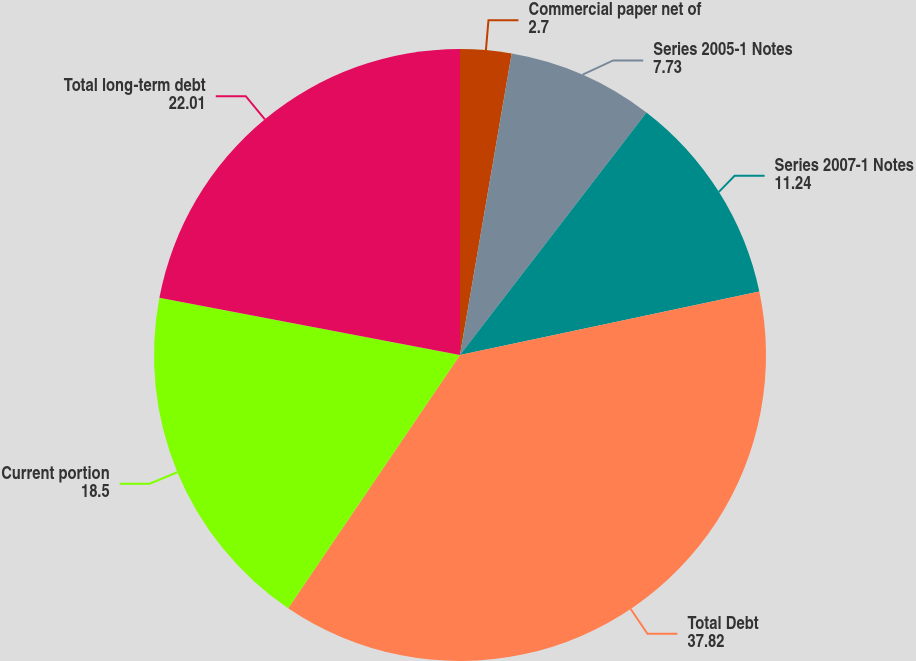Convert chart to OTSL. <chart><loc_0><loc_0><loc_500><loc_500><pie_chart><fcel>Commercial paper net of<fcel>Series 2005-1 Notes<fcel>Series 2007-1 Notes<fcel>Total Debt<fcel>Current portion<fcel>Total long-term debt<nl><fcel>2.7%<fcel>7.73%<fcel>11.24%<fcel>37.82%<fcel>18.5%<fcel>22.01%<nl></chart> 